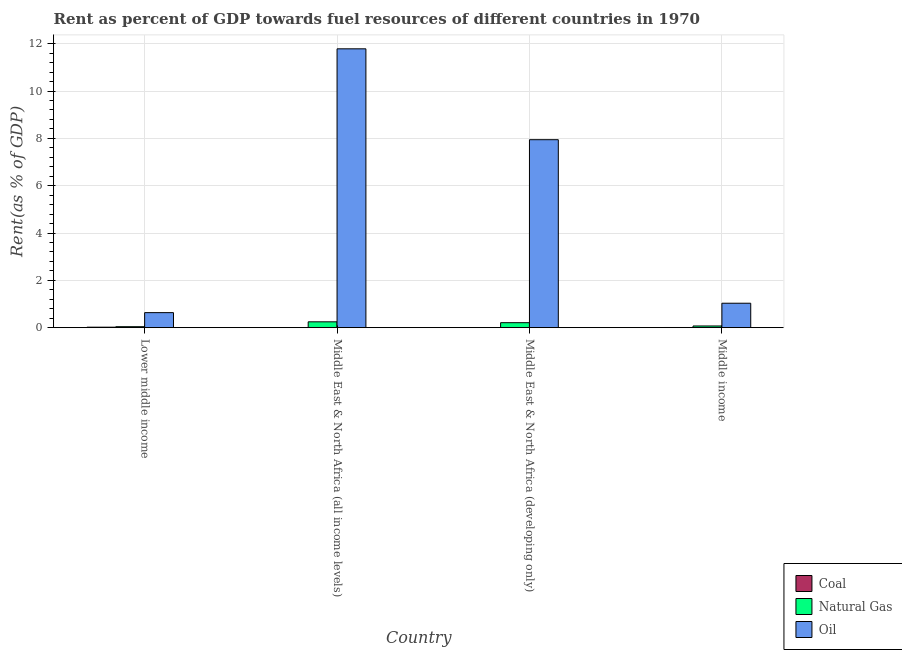How many different coloured bars are there?
Give a very brief answer. 3. Are the number of bars per tick equal to the number of legend labels?
Ensure brevity in your answer.  Yes. Are the number of bars on each tick of the X-axis equal?
Keep it short and to the point. Yes. How many bars are there on the 1st tick from the right?
Your answer should be very brief. 3. What is the label of the 3rd group of bars from the left?
Provide a short and direct response. Middle East & North Africa (developing only). In how many cases, is the number of bars for a given country not equal to the number of legend labels?
Ensure brevity in your answer.  0. What is the rent towards oil in Middle East & North Africa (all income levels)?
Your answer should be compact. 11.78. Across all countries, what is the maximum rent towards natural gas?
Provide a succinct answer. 0.25. Across all countries, what is the minimum rent towards coal?
Offer a terse response. 0. In which country was the rent towards coal maximum?
Offer a very short reply. Lower middle income. In which country was the rent towards coal minimum?
Your response must be concise. Middle East & North Africa (all income levels). What is the total rent towards oil in the graph?
Offer a terse response. 21.4. What is the difference between the rent towards oil in Middle East & North Africa (all income levels) and that in Middle East & North Africa (developing only)?
Ensure brevity in your answer.  3.84. What is the difference between the rent towards natural gas in Middle East & North Africa (developing only) and the rent towards oil in Middle East & North Africa (all income levels)?
Provide a succinct answer. -11.57. What is the average rent towards coal per country?
Provide a succinct answer. 0.01. What is the difference between the rent towards natural gas and rent towards oil in Middle East & North Africa (developing only)?
Your answer should be very brief. -7.73. In how many countries, is the rent towards oil greater than 4.4 %?
Ensure brevity in your answer.  2. What is the ratio of the rent towards oil in Middle East & North Africa (developing only) to that in Middle income?
Keep it short and to the point. 7.69. Is the rent towards natural gas in Middle East & North Africa (developing only) less than that in Middle income?
Give a very brief answer. No. What is the difference between the highest and the second highest rent towards oil?
Keep it short and to the point. 3.84. What is the difference between the highest and the lowest rent towards coal?
Provide a succinct answer. 0.02. In how many countries, is the rent towards oil greater than the average rent towards oil taken over all countries?
Your answer should be very brief. 2. What does the 1st bar from the left in Middle East & North Africa (developing only) represents?
Your response must be concise. Coal. What does the 3rd bar from the right in Lower middle income represents?
Offer a terse response. Coal. How many bars are there?
Provide a succinct answer. 12. How many legend labels are there?
Ensure brevity in your answer.  3. How are the legend labels stacked?
Provide a succinct answer. Vertical. What is the title of the graph?
Provide a short and direct response. Rent as percent of GDP towards fuel resources of different countries in 1970. Does "Domestic economy" appear as one of the legend labels in the graph?
Make the answer very short. No. What is the label or title of the X-axis?
Your answer should be compact. Country. What is the label or title of the Y-axis?
Ensure brevity in your answer.  Rent(as % of GDP). What is the Rent(as % of GDP) in Coal in Lower middle income?
Your answer should be very brief. 0.02. What is the Rent(as % of GDP) in Natural Gas in Lower middle income?
Your response must be concise. 0.04. What is the Rent(as % of GDP) in Oil in Lower middle income?
Your answer should be compact. 0.63. What is the Rent(as % of GDP) in Coal in Middle East & North Africa (all income levels)?
Give a very brief answer. 0. What is the Rent(as % of GDP) in Natural Gas in Middle East & North Africa (all income levels)?
Your answer should be compact. 0.25. What is the Rent(as % of GDP) in Oil in Middle East & North Africa (all income levels)?
Your response must be concise. 11.78. What is the Rent(as % of GDP) in Coal in Middle East & North Africa (developing only)?
Your answer should be very brief. 0. What is the Rent(as % of GDP) of Natural Gas in Middle East & North Africa (developing only)?
Offer a very short reply. 0.21. What is the Rent(as % of GDP) in Oil in Middle East & North Africa (developing only)?
Provide a succinct answer. 7.94. What is the Rent(as % of GDP) in Coal in Middle income?
Your answer should be compact. 0.01. What is the Rent(as % of GDP) in Natural Gas in Middle income?
Your response must be concise. 0.07. What is the Rent(as % of GDP) of Oil in Middle income?
Keep it short and to the point. 1.03. Across all countries, what is the maximum Rent(as % of GDP) in Coal?
Provide a short and direct response. 0.02. Across all countries, what is the maximum Rent(as % of GDP) of Natural Gas?
Offer a very short reply. 0.25. Across all countries, what is the maximum Rent(as % of GDP) of Oil?
Offer a terse response. 11.78. Across all countries, what is the minimum Rent(as % of GDP) in Coal?
Offer a very short reply. 0. Across all countries, what is the minimum Rent(as % of GDP) of Natural Gas?
Ensure brevity in your answer.  0.04. Across all countries, what is the minimum Rent(as % of GDP) in Oil?
Keep it short and to the point. 0.63. What is the total Rent(as % of GDP) in Coal in the graph?
Offer a terse response. 0.03. What is the total Rent(as % of GDP) in Natural Gas in the graph?
Provide a succinct answer. 0.57. What is the total Rent(as % of GDP) in Oil in the graph?
Your answer should be very brief. 21.4. What is the difference between the Rent(as % of GDP) of Natural Gas in Lower middle income and that in Middle East & North Africa (all income levels)?
Ensure brevity in your answer.  -0.21. What is the difference between the Rent(as % of GDP) in Oil in Lower middle income and that in Middle East & North Africa (all income levels)?
Your answer should be compact. -11.15. What is the difference between the Rent(as % of GDP) in Coal in Lower middle income and that in Middle East & North Africa (developing only)?
Give a very brief answer. 0.02. What is the difference between the Rent(as % of GDP) in Natural Gas in Lower middle income and that in Middle East & North Africa (developing only)?
Make the answer very short. -0.17. What is the difference between the Rent(as % of GDP) of Oil in Lower middle income and that in Middle East & North Africa (developing only)?
Your answer should be very brief. -7.31. What is the difference between the Rent(as % of GDP) of Coal in Lower middle income and that in Middle income?
Give a very brief answer. 0.01. What is the difference between the Rent(as % of GDP) of Natural Gas in Lower middle income and that in Middle income?
Your answer should be compact. -0.03. What is the difference between the Rent(as % of GDP) in Oil in Lower middle income and that in Middle income?
Provide a short and direct response. -0.4. What is the difference between the Rent(as % of GDP) of Coal in Middle East & North Africa (all income levels) and that in Middle East & North Africa (developing only)?
Your response must be concise. -0. What is the difference between the Rent(as % of GDP) in Natural Gas in Middle East & North Africa (all income levels) and that in Middle East & North Africa (developing only)?
Ensure brevity in your answer.  0.04. What is the difference between the Rent(as % of GDP) in Oil in Middle East & North Africa (all income levels) and that in Middle East & North Africa (developing only)?
Offer a very short reply. 3.84. What is the difference between the Rent(as % of GDP) of Coal in Middle East & North Africa (all income levels) and that in Middle income?
Offer a terse response. -0.01. What is the difference between the Rent(as % of GDP) in Natural Gas in Middle East & North Africa (all income levels) and that in Middle income?
Your answer should be very brief. 0.18. What is the difference between the Rent(as % of GDP) in Oil in Middle East & North Africa (all income levels) and that in Middle income?
Provide a succinct answer. 10.75. What is the difference between the Rent(as % of GDP) of Coal in Middle East & North Africa (developing only) and that in Middle income?
Offer a very short reply. -0.01. What is the difference between the Rent(as % of GDP) in Natural Gas in Middle East & North Africa (developing only) and that in Middle income?
Give a very brief answer. 0.14. What is the difference between the Rent(as % of GDP) in Oil in Middle East & North Africa (developing only) and that in Middle income?
Ensure brevity in your answer.  6.91. What is the difference between the Rent(as % of GDP) of Coal in Lower middle income and the Rent(as % of GDP) of Natural Gas in Middle East & North Africa (all income levels)?
Ensure brevity in your answer.  -0.23. What is the difference between the Rent(as % of GDP) of Coal in Lower middle income and the Rent(as % of GDP) of Oil in Middle East & North Africa (all income levels)?
Your answer should be very brief. -11.76. What is the difference between the Rent(as % of GDP) in Natural Gas in Lower middle income and the Rent(as % of GDP) in Oil in Middle East & North Africa (all income levels)?
Offer a terse response. -11.74. What is the difference between the Rent(as % of GDP) in Coal in Lower middle income and the Rent(as % of GDP) in Natural Gas in Middle East & North Africa (developing only)?
Give a very brief answer. -0.19. What is the difference between the Rent(as % of GDP) of Coal in Lower middle income and the Rent(as % of GDP) of Oil in Middle East & North Africa (developing only)?
Offer a very short reply. -7.92. What is the difference between the Rent(as % of GDP) of Natural Gas in Lower middle income and the Rent(as % of GDP) of Oil in Middle East & North Africa (developing only)?
Offer a very short reply. -7.9. What is the difference between the Rent(as % of GDP) of Coal in Lower middle income and the Rent(as % of GDP) of Natural Gas in Middle income?
Offer a very short reply. -0.05. What is the difference between the Rent(as % of GDP) in Coal in Lower middle income and the Rent(as % of GDP) in Oil in Middle income?
Provide a short and direct response. -1.01. What is the difference between the Rent(as % of GDP) in Natural Gas in Lower middle income and the Rent(as % of GDP) in Oil in Middle income?
Keep it short and to the point. -0.99. What is the difference between the Rent(as % of GDP) of Coal in Middle East & North Africa (all income levels) and the Rent(as % of GDP) of Natural Gas in Middle East & North Africa (developing only)?
Your answer should be compact. -0.21. What is the difference between the Rent(as % of GDP) of Coal in Middle East & North Africa (all income levels) and the Rent(as % of GDP) of Oil in Middle East & North Africa (developing only)?
Your answer should be very brief. -7.94. What is the difference between the Rent(as % of GDP) of Natural Gas in Middle East & North Africa (all income levels) and the Rent(as % of GDP) of Oil in Middle East & North Africa (developing only)?
Your answer should be compact. -7.7. What is the difference between the Rent(as % of GDP) in Coal in Middle East & North Africa (all income levels) and the Rent(as % of GDP) in Natural Gas in Middle income?
Provide a succinct answer. -0.07. What is the difference between the Rent(as % of GDP) in Coal in Middle East & North Africa (all income levels) and the Rent(as % of GDP) in Oil in Middle income?
Give a very brief answer. -1.03. What is the difference between the Rent(as % of GDP) of Natural Gas in Middle East & North Africa (all income levels) and the Rent(as % of GDP) of Oil in Middle income?
Your answer should be very brief. -0.79. What is the difference between the Rent(as % of GDP) of Coal in Middle East & North Africa (developing only) and the Rent(as % of GDP) of Natural Gas in Middle income?
Offer a very short reply. -0.07. What is the difference between the Rent(as % of GDP) in Coal in Middle East & North Africa (developing only) and the Rent(as % of GDP) in Oil in Middle income?
Your response must be concise. -1.03. What is the difference between the Rent(as % of GDP) in Natural Gas in Middle East & North Africa (developing only) and the Rent(as % of GDP) in Oil in Middle income?
Keep it short and to the point. -0.82. What is the average Rent(as % of GDP) of Coal per country?
Provide a short and direct response. 0.01. What is the average Rent(as % of GDP) of Natural Gas per country?
Your response must be concise. 0.14. What is the average Rent(as % of GDP) in Oil per country?
Provide a succinct answer. 5.35. What is the difference between the Rent(as % of GDP) of Coal and Rent(as % of GDP) of Natural Gas in Lower middle income?
Your response must be concise. -0.02. What is the difference between the Rent(as % of GDP) in Coal and Rent(as % of GDP) in Oil in Lower middle income?
Offer a very short reply. -0.61. What is the difference between the Rent(as % of GDP) in Natural Gas and Rent(as % of GDP) in Oil in Lower middle income?
Your answer should be very brief. -0.59. What is the difference between the Rent(as % of GDP) in Coal and Rent(as % of GDP) in Natural Gas in Middle East & North Africa (all income levels)?
Your response must be concise. -0.25. What is the difference between the Rent(as % of GDP) of Coal and Rent(as % of GDP) of Oil in Middle East & North Africa (all income levels)?
Keep it short and to the point. -11.78. What is the difference between the Rent(as % of GDP) in Natural Gas and Rent(as % of GDP) in Oil in Middle East & North Africa (all income levels)?
Provide a succinct answer. -11.54. What is the difference between the Rent(as % of GDP) of Coal and Rent(as % of GDP) of Natural Gas in Middle East & North Africa (developing only)?
Keep it short and to the point. -0.21. What is the difference between the Rent(as % of GDP) in Coal and Rent(as % of GDP) in Oil in Middle East & North Africa (developing only)?
Make the answer very short. -7.94. What is the difference between the Rent(as % of GDP) in Natural Gas and Rent(as % of GDP) in Oil in Middle East & North Africa (developing only)?
Offer a very short reply. -7.73. What is the difference between the Rent(as % of GDP) in Coal and Rent(as % of GDP) in Natural Gas in Middle income?
Provide a short and direct response. -0.06. What is the difference between the Rent(as % of GDP) of Coal and Rent(as % of GDP) of Oil in Middle income?
Your answer should be very brief. -1.02. What is the difference between the Rent(as % of GDP) in Natural Gas and Rent(as % of GDP) in Oil in Middle income?
Provide a short and direct response. -0.96. What is the ratio of the Rent(as % of GDP) of Coal in Lower middle income to that in Middle East & North Africa (all income levels)?
Your answer should be very brief. 35.4. What is the ratio of the Rent(as % of GDP) of Natural Gas in Lower middle income to that in Middle East & North Africa (all income levels)?
Offer a terse response. 0.17. What is the ratio of the Rent(as % of GDP) of Oil in Lower middle income to that in Middle East & North Africa (all income levels)?
Keep it short and to the point. 0.05. What is the ratio of the Rent(as % of GDP) of Coal in Lower middle income to that in Middle East & North Africa (developing only)?
Your response must be concise. 25.06. What is the ratio of the Rent(as % of GDP) in Natural Gas in Lower middle income to that in Middle East & North Africa (developing only)?
Provide a short and direct response. 0.2. What is the ratio of the Rent(as % of GDP) in Oil in Lower middle income to that in Middle East & North Africa (developing only)?
Your response must be concise. 0.08. What is the ratio of the Rent(as % of GDP) of Coal in Lower middle income to that in Middle income?
Provide a succinct answer. 2.78. What is the ratio of the Rent(as % of GDP) of Natural Gas in Lower middle income to that in Middle income?
Offer a very short reply. 0.58. What is the ratio of the Rent(as % of GDP) of Oil in Lower middle income to that in Middle income?
Give a very brief answer. 0.61. What is the ratio of the Rent(as % of GDP) of Coal in Middle East & North Africa (all income levels) to that in Middle East & North Africa (developing only)?
Make the answer very short. 0.71. What is the ratio of the Rent(as % of GDP) of Natural Gas in Middle East & North Africa (all income levels) to that in Middle East & North Africa (developing only)?
Offer a terse response. 1.17. What is the ratio of the Rent(as % of GDP) of Oil in Middle East & North Africa (all income levels) to that in Middle East & North Africa (developing only)?
Offer a terse response. 1.48. What is the ratio of the Rent(as % of GDP) of Coal in Middle East & North Africa (all income levels) to that in Middle income?
Your answer should be compact. 0.08. What is the ratio of the Rent(as % of GDP) of Natural Gas in Middle East & North Africa (all income levels) to that in Middle income?
Offer a very short reply. 3.45. What is the ratio of the Rent(as % of GDP) of Oil in Middle East & North Africa (all income levels) to that in Middle income?
Provide a succinct answer. 11.41. What is the ratio of the Rent(as % of GDP) in Coal in Middle East & North Africa (developing only) to that in Middle income?
Your answer should be compact. 0.11. What is the ratio of the Rent(as % of GDP) of Natural Gas in Middle East & North Africa (developing only) to that in Middle income?
Keep it short and to the point. 2.94. What is the ratio of the Rent(as % of GDP) in Oil in Middle East & North Africa (developing only) to that in Middle income?
Your answer should be very brief. 7.69. What is the difference between the highest and the second highest Rent(as % of GDP) in Coal?
Provide a short and direct response. 0.01. What is the difference between the highest and the second highest Rent(as % of GDP) of Natural Gas?
Provide a short and direct response. 0.04. What is the difference between the highest and the second highest Rent(as % of GDP) of Oil?
Make the answer very short. 3.84. What is the difference between the highest and the lowest Rent(as % of GDP) of Natural Gas?
Offer a very short reply. 0.21. What is the difference between the highest and the lowest Rent(as % of GDP) of Oil?
Your answer should be compact. 11.15. 